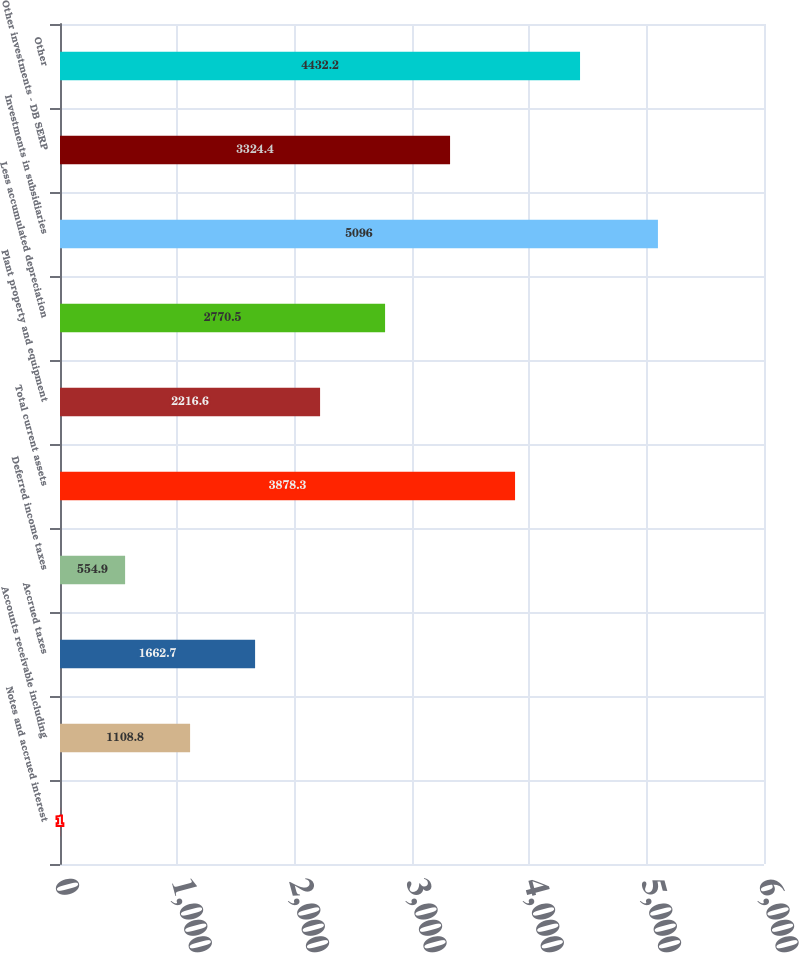Convert chart. <chart><loc_0><loc_0><loc_500><loc_500><bar_chart><fcel>Notes and accrued interest<fcel>Accounts receivable including<fcel>Accrued taxes<fcel>Deferred income taxes<fcel>Total current assets<fcel>Plant property and equipment<fcel>Less accumulated depreciation<fcel>Investments in subsidiaries<fcel>Other investments - DB SERP<fcel>Other<nl><fcel>1<fcel>1108.8<fcel>1662.7<fcel>554.9<fcel>3878.3<fcel>2216.6<fcel>2770.5<fcel>5096<fcel>3324.4<fcel>4432.2<nl></chart> 